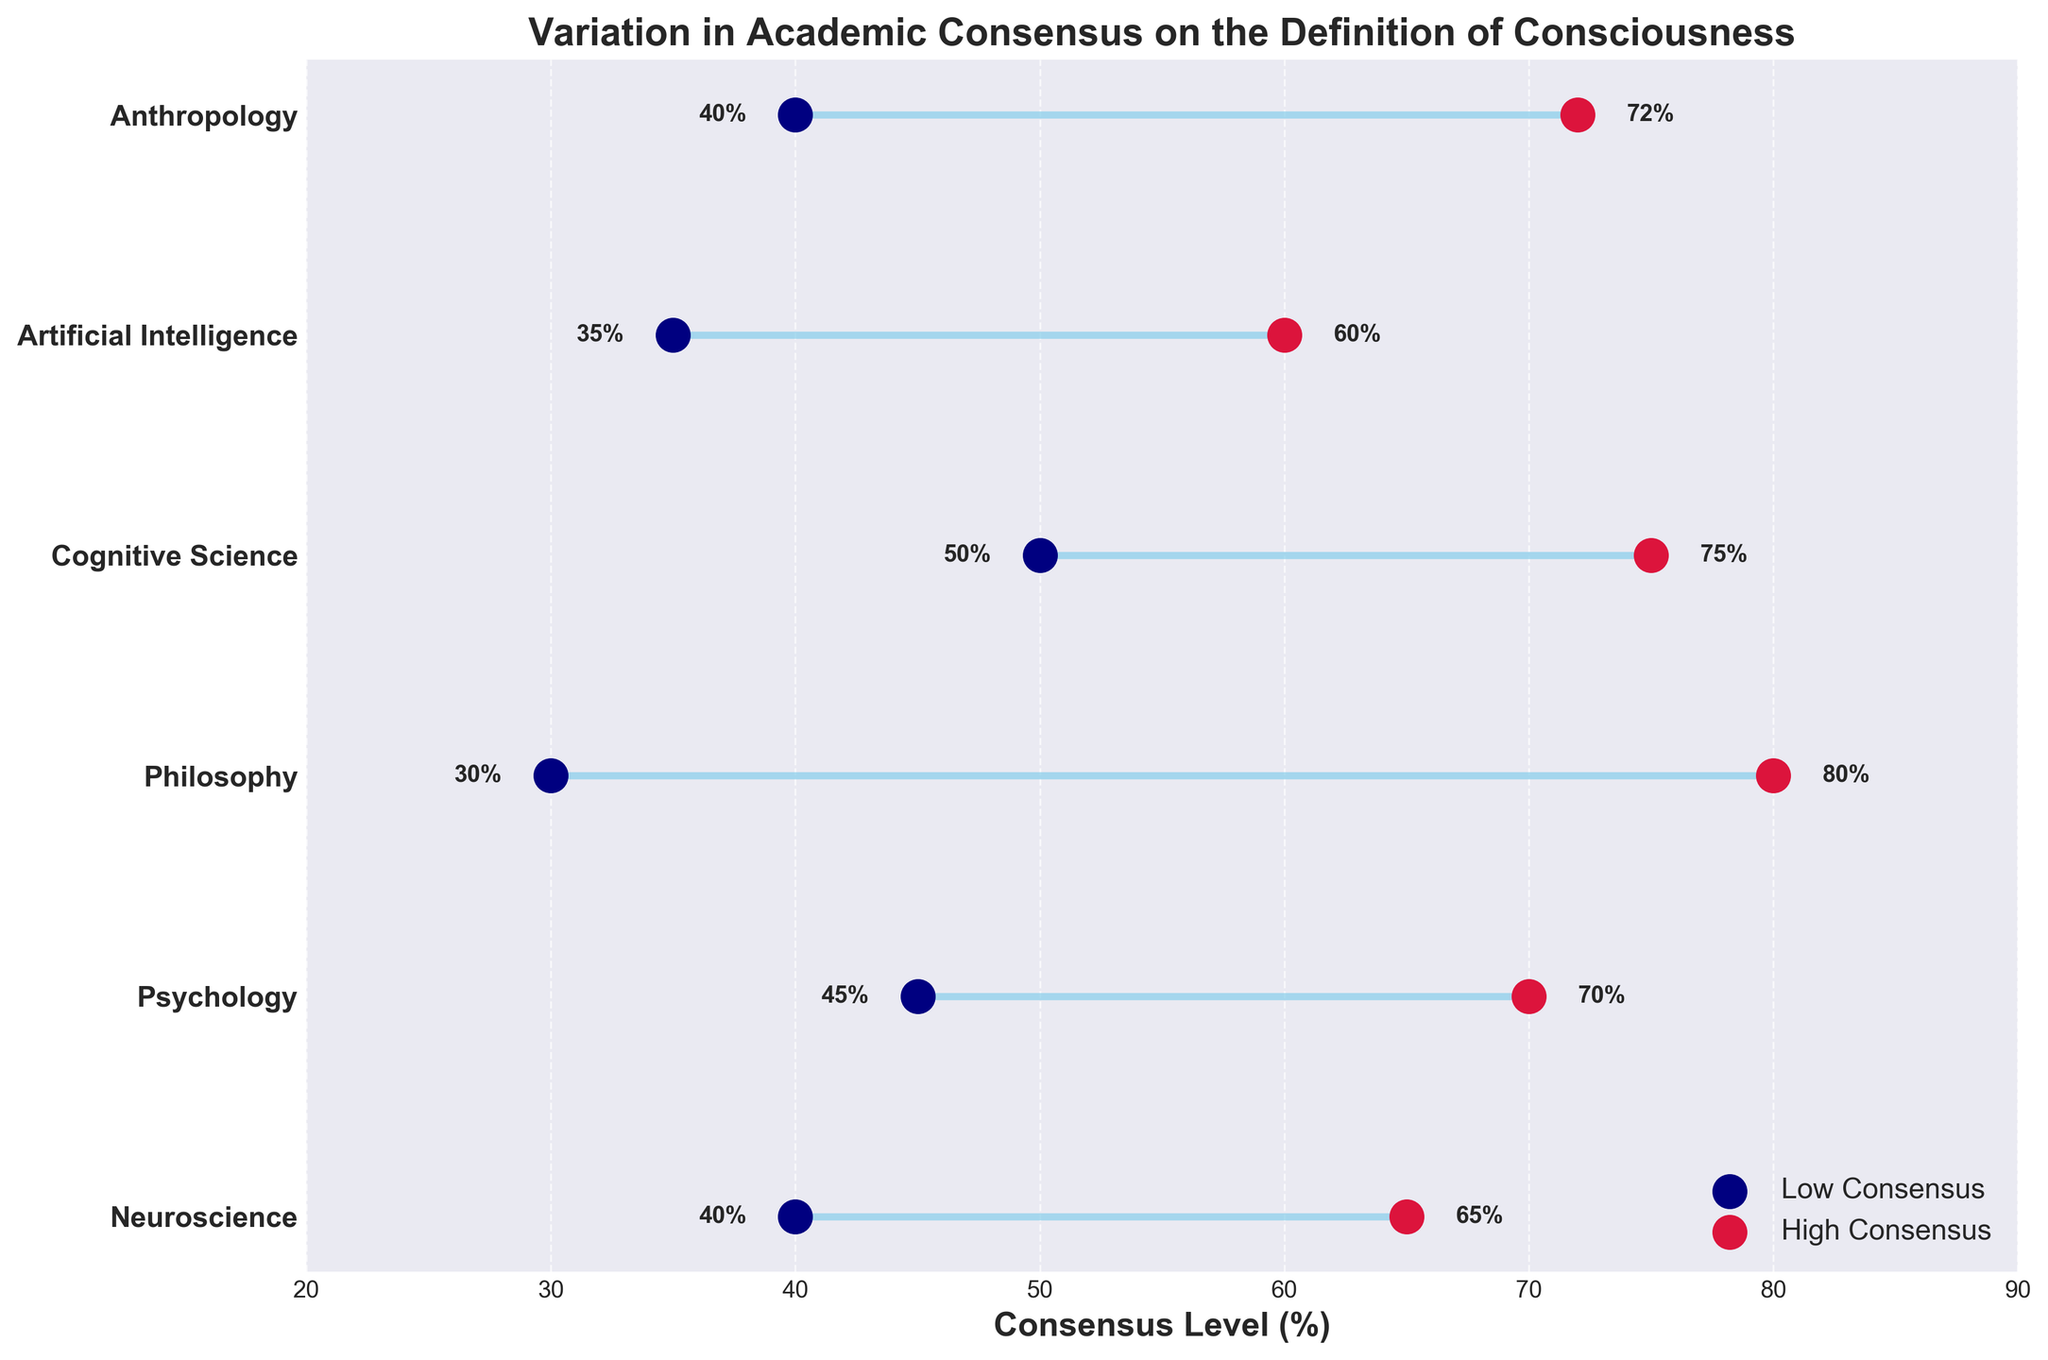How many academic disciplines are represented in the figure? Count the number of distinct academic disciplines listed on the y-axis. There are six disciplines: Neuroscience, Psychology, Philosophy, Cognitive Science, Artificial Intelligence, and Anthropology.
Answer: Six What are the high and low consensus levels for the Philosophy discipline? Locate the "Philosophy" discipline on the y-axis and note the values associated with the endpoints of the dumbbell. The low consensus is at 30%, and the high consensus is at 80%.
Answer: 30% and 80% Which discipline shows the smallest range in consensus levels? Calculate the range (high consensus minus low consensus) for each discipline and compare. Cognitive Science has a range of 25%, which is the smallest among the disciplines.
Answer: Cognitive Science Which two disciplines have the same low consensus level? Look for matching values in the low consensus points on the x-axis. Both Neuroscience and Anthropology have a low consensus level set at 40%.
Answer: Neuroscience and Anthropology What is the average high consensus level across all disciplines? Add the high consensus values of all disciplines (65 + 70 + 80 + 75 + 60 + 72) and then divide by the number of disciplines, which is 6. The total is 422, and 422 divided by 6 equals approximately 70.33%.
Answer: 70.33% Which discipline has the highest high consensus level? Identify the highest consensus level point on the x-axis and find the corresponding discipline on the y-axis. Philosophy has the highest high consensus level at 80%.
Answer: Philosophy What is the total range of consensus levels for all disciplines together? Determine the maximum high consensus and the minimum low consensus from all disciplines. The maximum high consensus is 80% (Philosophy), and the minimum low consensus is 30% (Philosophy). The total range is 80% - 30% = 50%.
Answer: 50% Which disciplines have their high consensus levels above 70%? Identify disciplines where the high consensus value exceeds 70%. They are Psychology (70%), Philosophy (80%), Cognitive Science (75%), and Anthropology (72%).
Answer: Psychology, Philosophy, Cognitive Science, and Anthropology 